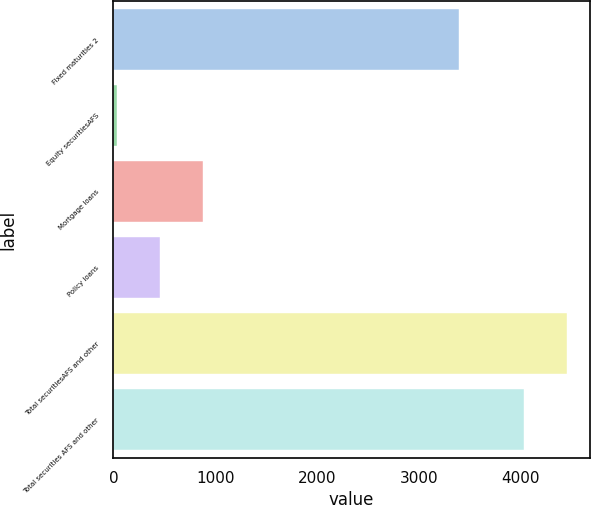Convert chart to OTSL. <chart><loc_0><loc_0><loc_500><loc_500><bar_chart><fcel>Fixed maturities 2<fcel>Equity securitiesAFS<fcel>Mortgage loans<fcel>Policy loans<fcel>Total securitiesAFS and other<fcel>Total securities AFS and other<nl><fcel>3396<fcel>36<fcel>883.2<fcel>459.6<fcel>4452.6<fcel>4029<nl></chart> 